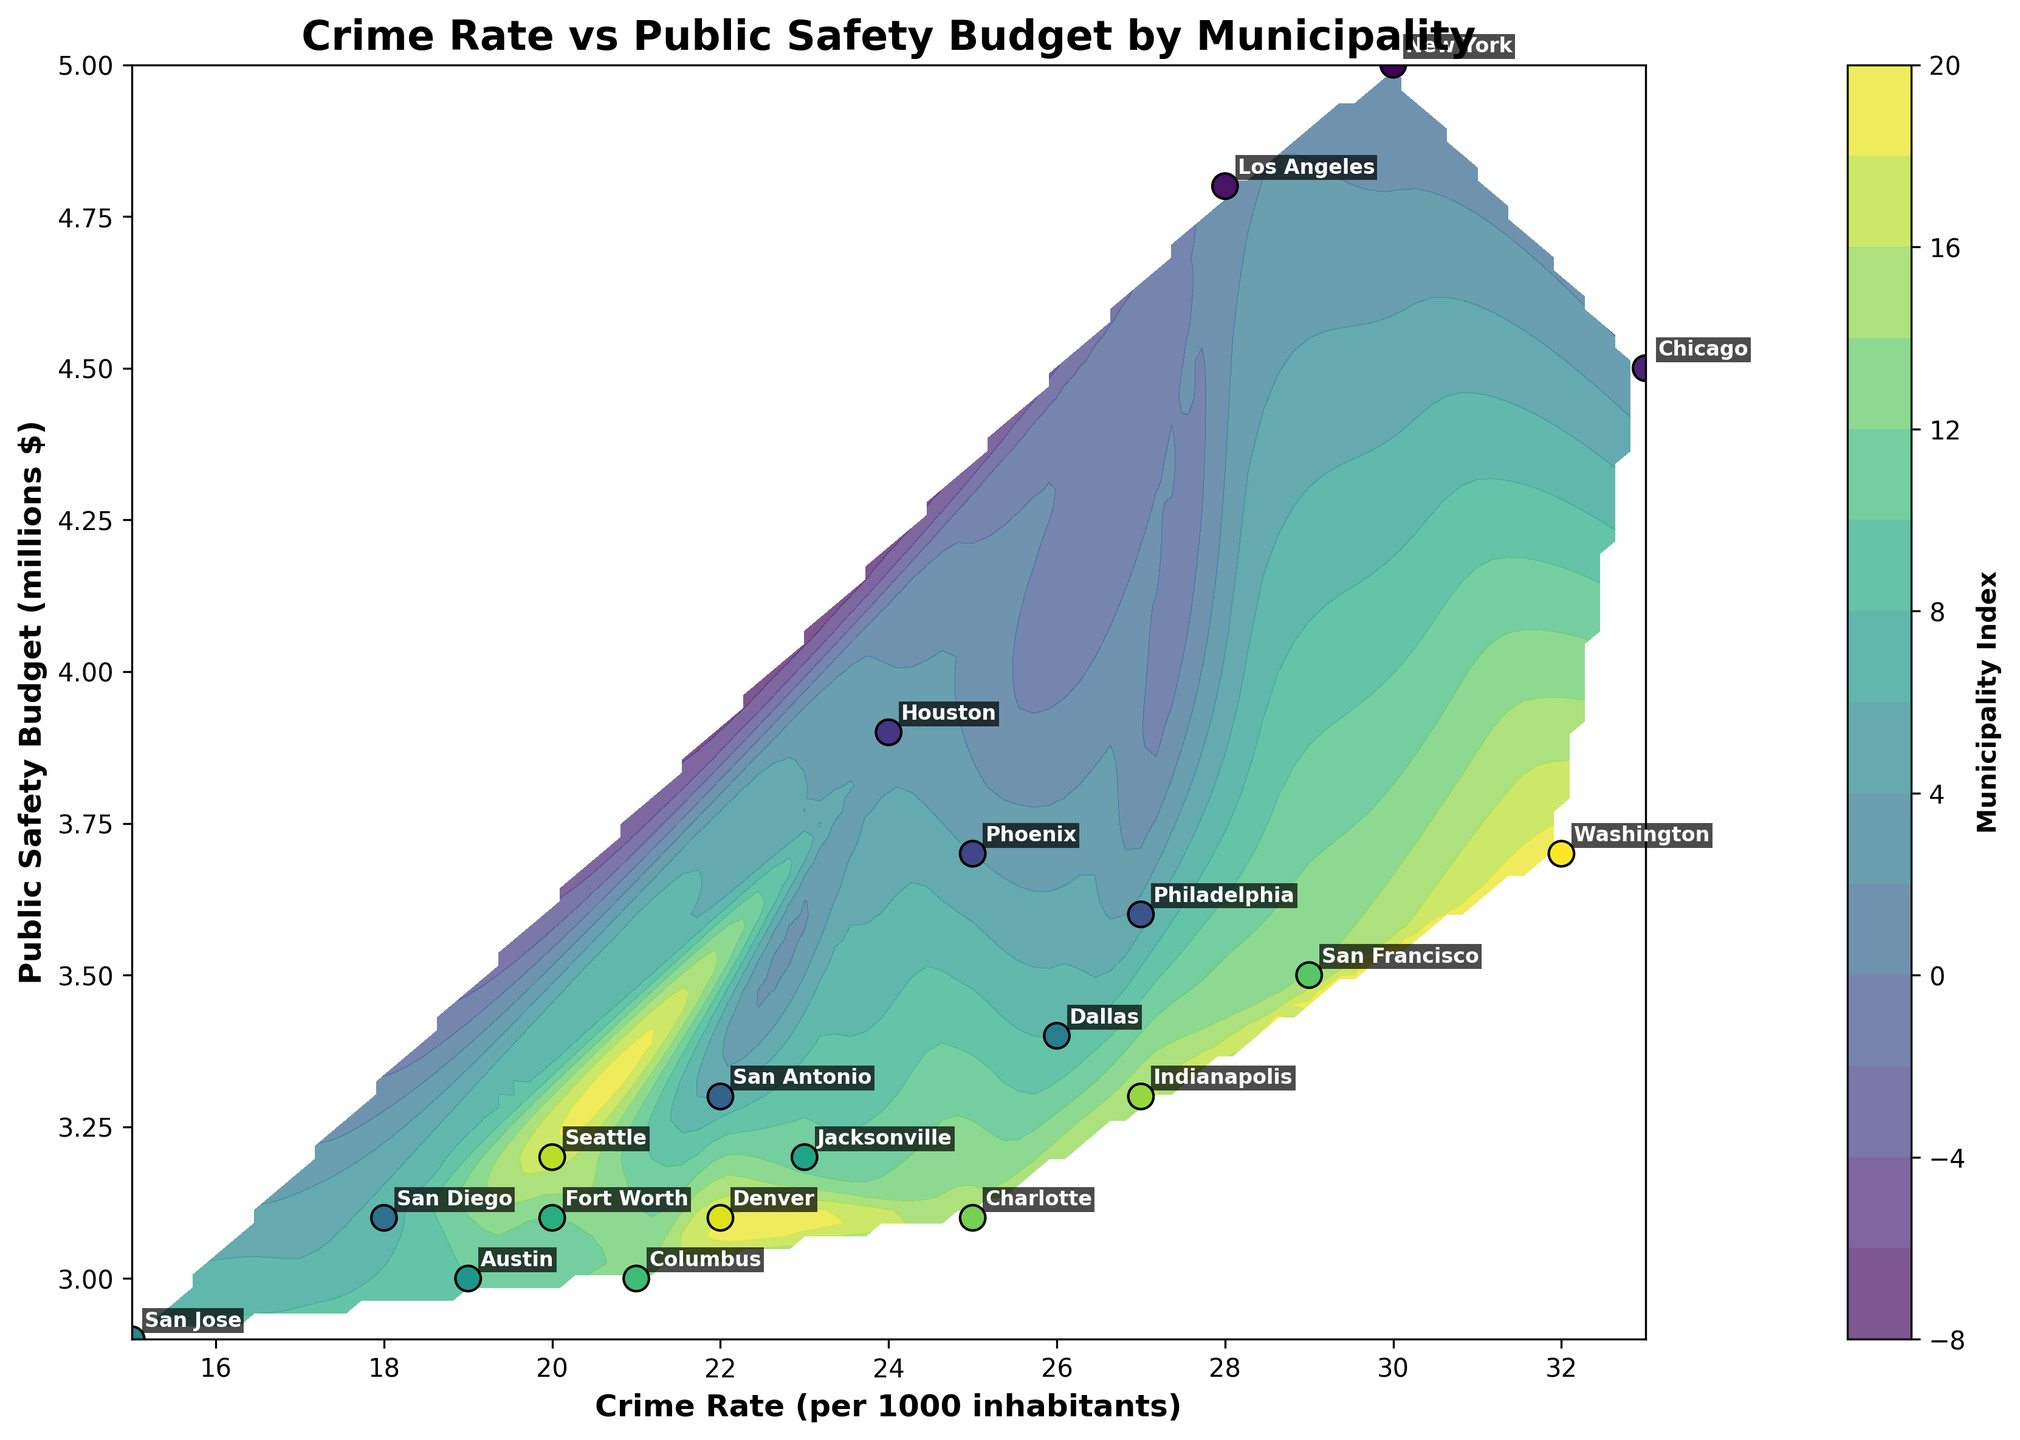What is the title of the plot? The title is typically positioned at the top of the figure in a bold and slightly larger font. In this plot, the title reads "Crime Rate vs Public Safety Budget by Municipality".
Answer: Crime Rate vs Public Safety Budget by Municipality How many municipalities are represented in the plot? To determine the number of municipalities, we can count the number of unique annotation labels in the scatter plot. Each point represents one municipality, and there are 20 distinct points.
Answer: 20 Which municipality has the highest crime rate? To identify the municipality with the highest crime rate, we look for the point with the highest x-value and check its label. The highest crime rate appears near 33 per 1000 inhabitants, corresponding to "Chicago".
Answer: Chicago What is the average public safety budget for the municipalities? To calculate the average public safety budget, one must sum the y-axis values (public safety budgets) and divide by the number of municipalities. Summing all budgets ($5000000 + $4800000 + ... + $3700000) and dividing by 20 gives: (89400000 / 20) = $4470000.
Answer: $4470000 Comparing New York and San Diego, which has a higher public safety budget? By locating the points representing New York and San Diego on the y-axis, New York is at $5,000,000, and San Diego is at $3,100,000. Therefore, New York has a higher budget.
Answer: New York Among the municipalities with a crime rate of 25 per 1000 inhabitants, which has the lowest public safety budget? Identify points at x = 25 and compare their y-values. Phoenix and Charlotte both have a crime rate of 25, but Phoenix has the lower budget at $3,700,000 compared to Charlotte's $3,100,000.
Answer: Phoenix Is there a clear correlation between crime rate and public safety budget as seen in the plot? By visually inspecting the scatter points and contour lines, there is no obvious linear or clear pattern linking higher crime rates to higher public safety budgets, indicating a lack of strong correlation.
Answer: No Which municipality has a higher crime rate: Denver or Indianapolis? Analyzing their positions on the x-axis, Denver has a crime rate of 22, and Indianapolis has a crime rate of 27. Thus, Indianapolis has a higher crime rate.
Answer: Indianapolis What is the range of public safety budgets across all municipalities? To find the range, subtract the smallest budget from the largest, which are $2,900,000 (San Jose) and $5,000,000 (New York), respectively. So, $5,000,000 - $2,900,000 = $2,100,000.
Answer: $2,100,000 